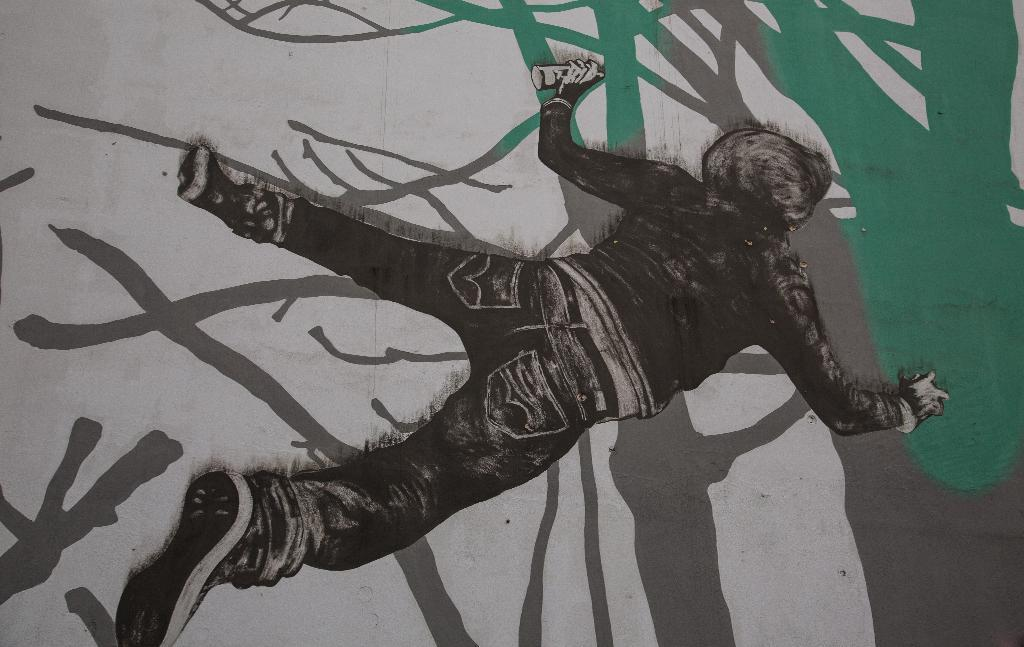What type of artwork is shown in the image? The image is a painting. What is the main subject of the painting? The painting depicts a person lying on the floor. What is the person wearing in the painting? The person is wearing a jacket. What object is the person holding in the painting? The person is holding a spray bottle in their hand. What type of ornament is hanging from the door in the painting? There is no door or ornament present in the painting; it depicts a person lying on the floor and holding a spray bottle. What type of dress is the person wearing in the painting? The person is not wearing a dress in the painting; they are wearing a jacket. 